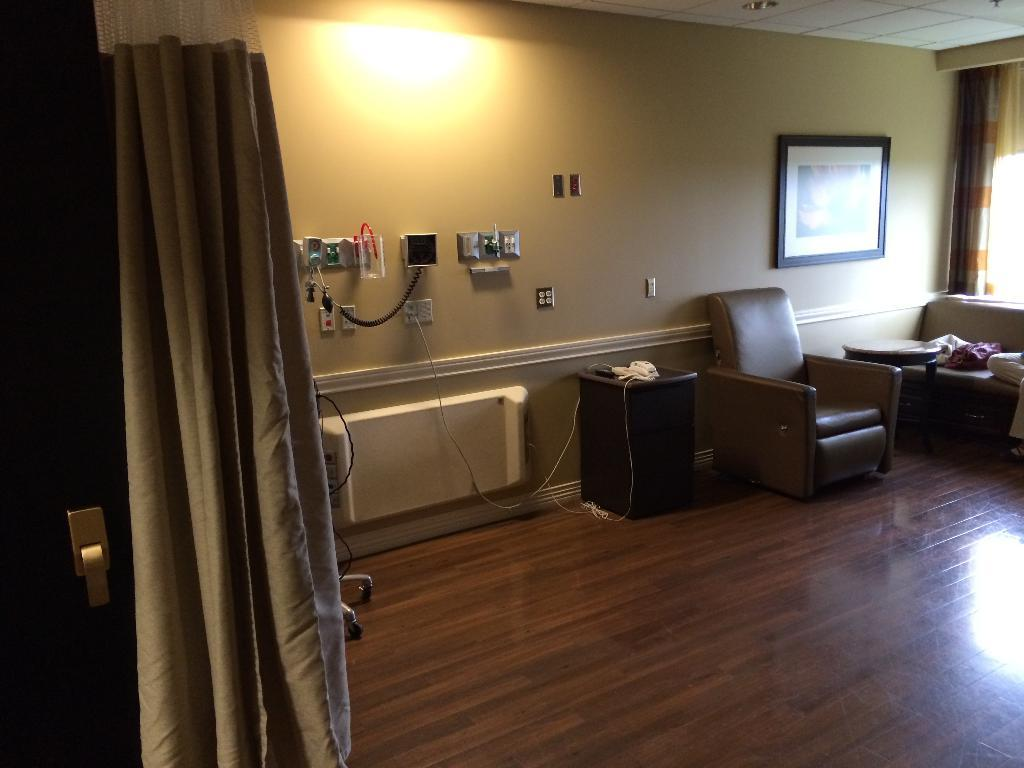What is one of the main features of the room in the image? There is a door in the image. What type of window treatment is present in the room? There are curtains in the image. What type of furniture can be seen in the room? There are chairs in the image. What is hanging on the wall in the image? There are items on the wall in the image, including a frame. What type of advertisement can be seen on the wall in the image? There is no advertisement present in the image; it only features a frame on the wall. 